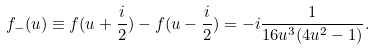Convert formula to latex. <formula><loc_0><loc_0><loc_500><loc_500>f _ { - } ( u ) \equiv f ( u + \frac { i } { 2 } ) - f ( u - \frac { i } { 2 } ) = - i \frac { 1 } { 1 6 u ^ { 3 } ( 4 u ^ { 2 } - 1 ) } .</formula> 